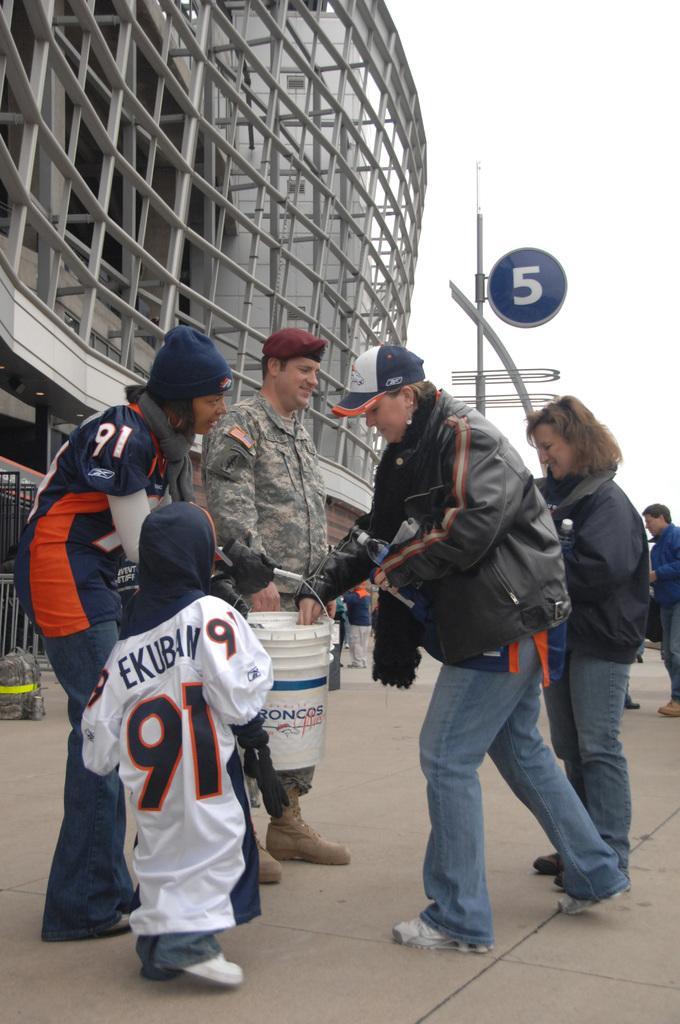How would you summarize this image in a sentence or two? In this image there are two men, two women and a kid beside the woman there is another man, they are standing on a path, in the background there is building and a sky. 